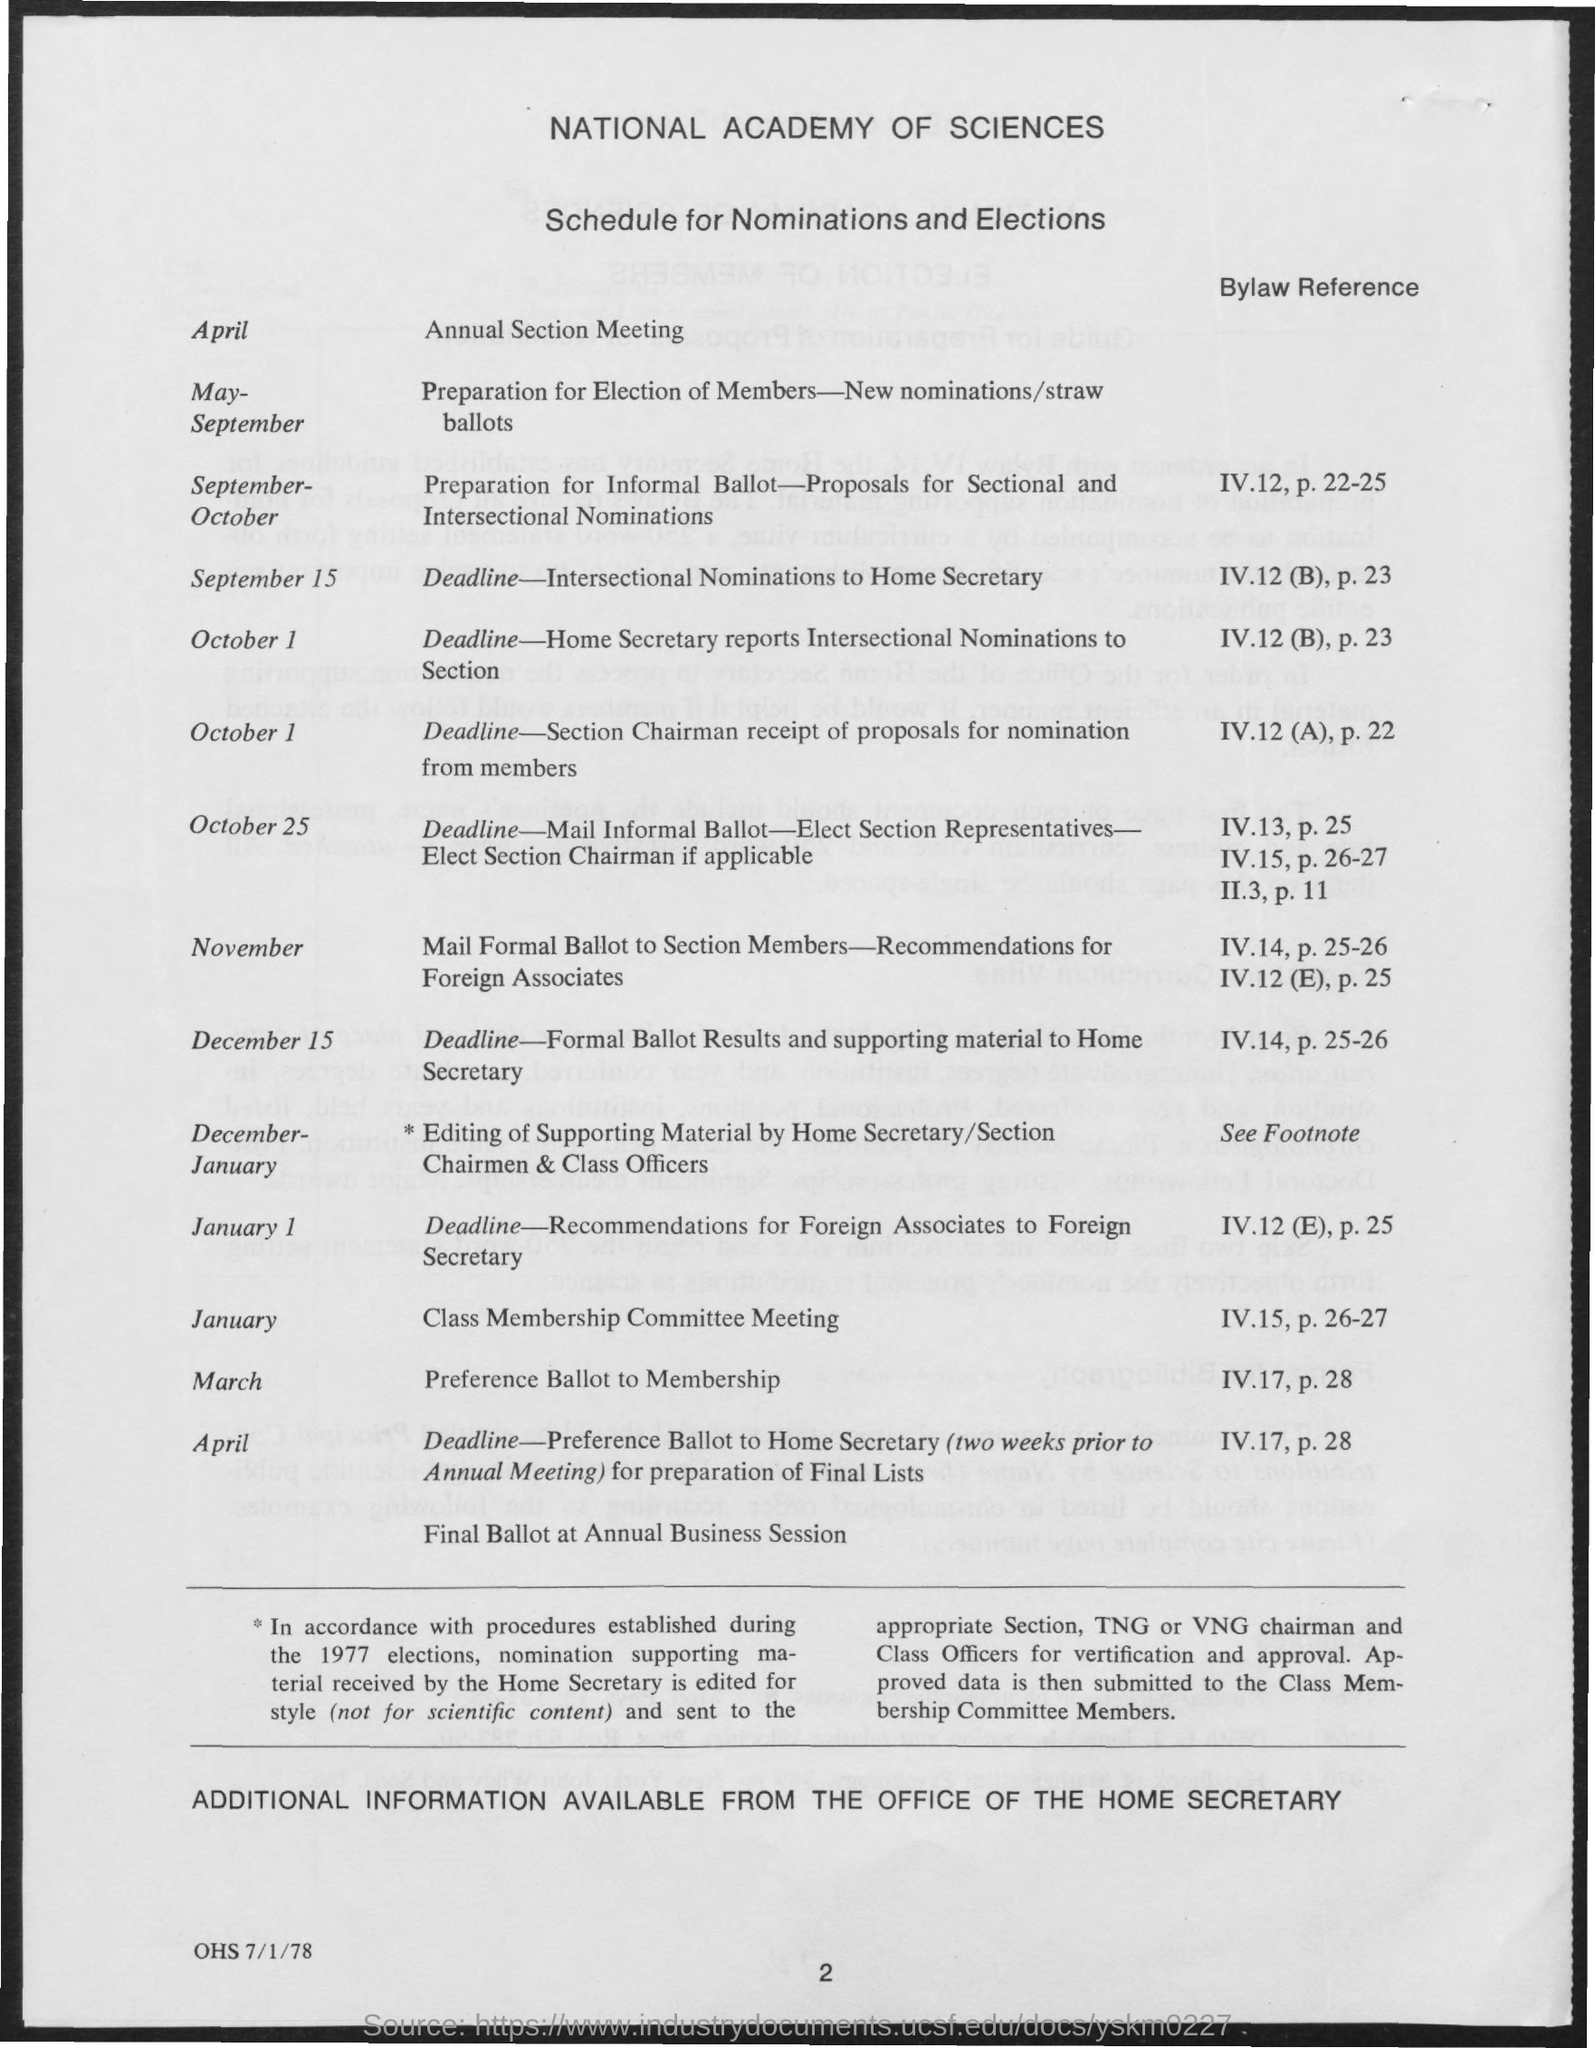Specify some key components in this picture. The schedule for the month of November is as follows: the foreign associates' recommendations for the ballot will be mailed formally, and the formal ballot will be given to section members. The annual section meeting is scheduled for April. The Class Membership Committee will be holding their meeting in January. For the months of May to September, the schedule includes preparation for the election of members, with new nominations/straw ballots. In March, the schedule will be used to convert the preference ballot to membership. 